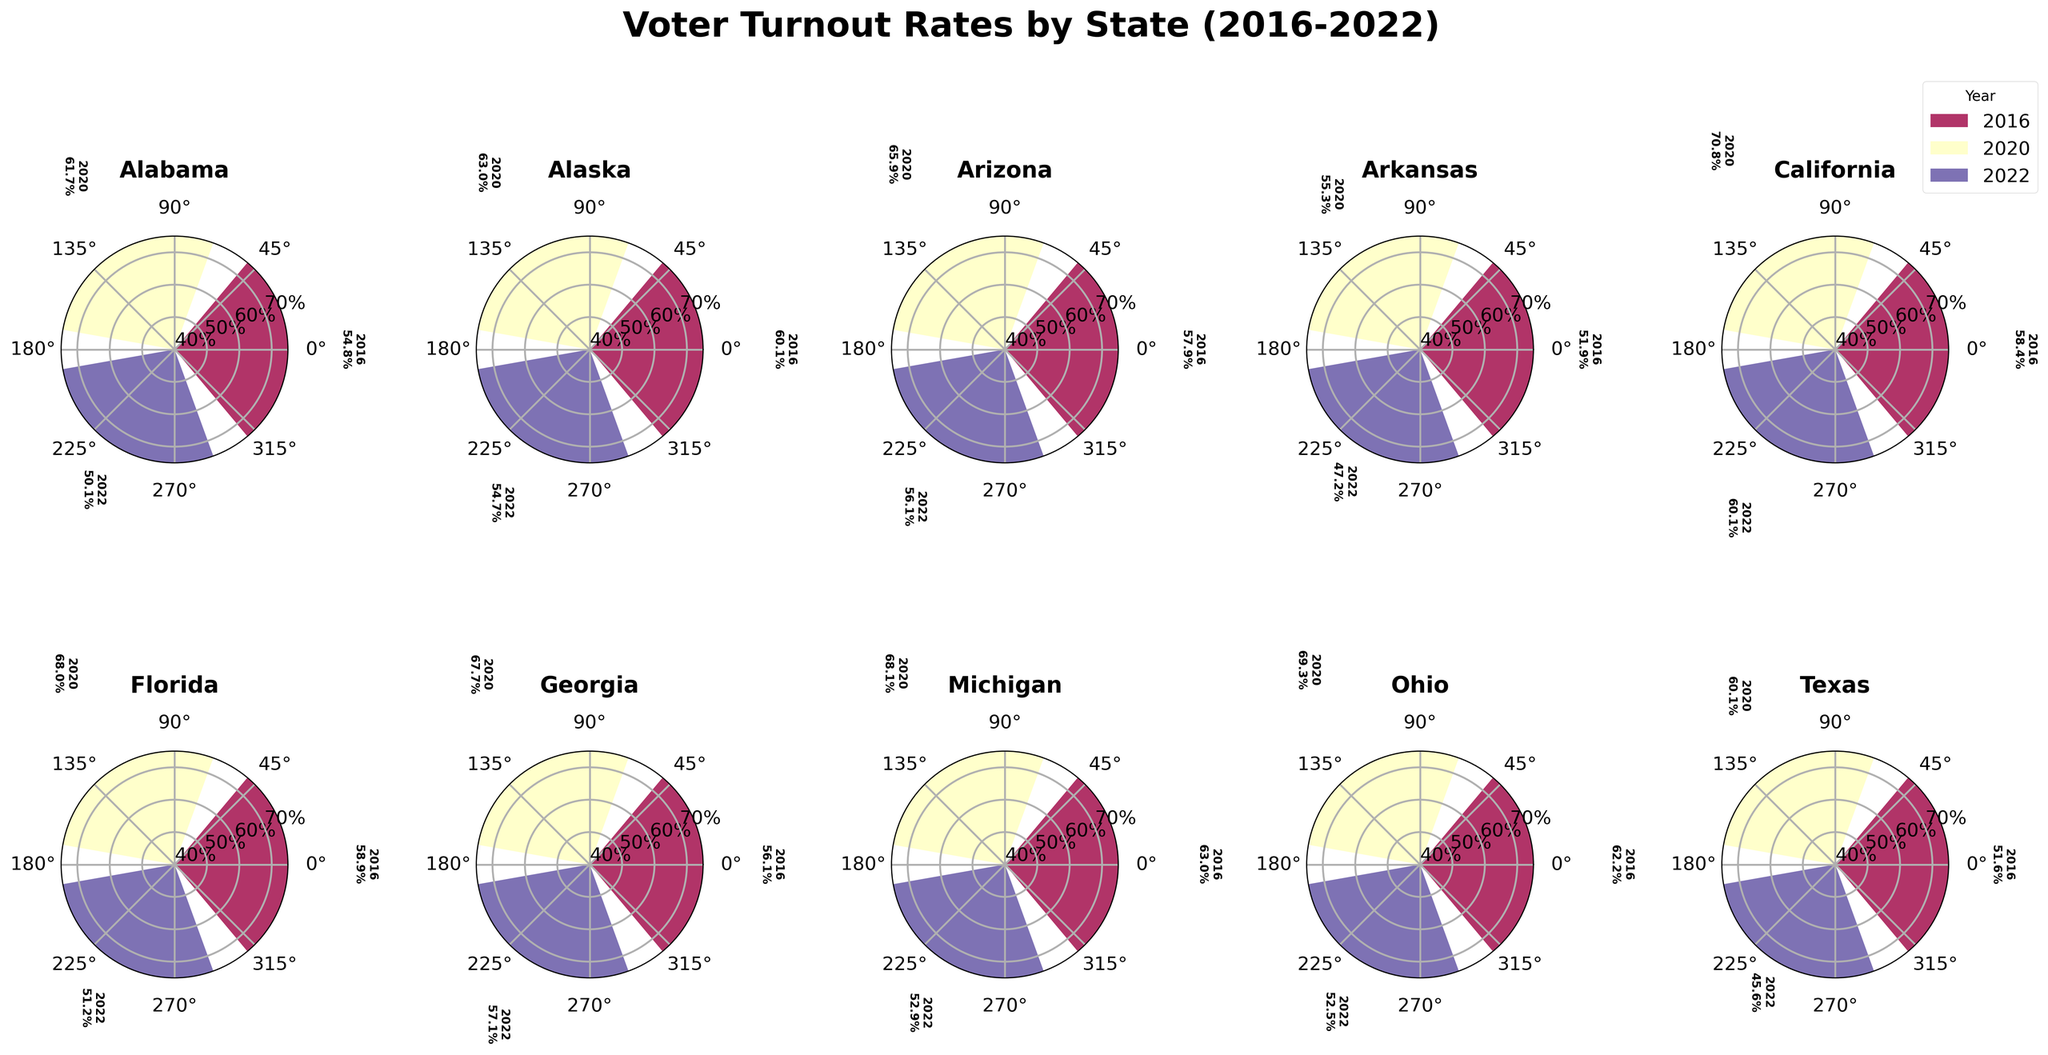how many states are represented in the figure? Count the number of unique states listed as titles above each subplot. There are 10 states represented in the figure.
Answer: 10 which year had the highest voter turnout in california? For California's subplot, compare the voter turnout percentages labeled for each year (2016, 2020, 2022). The highest turnout is for the year 2020 with 70.8%.
Answer: 2020 what is the range of voter turnout rates in florida over the past three elections? Identify the highest and lowest voter turnout rates for Florida (68.0% in 2020 and 51.2% in 2022). Calculate the range by subtracting the lowest value from the highest value (68.0 - 51.2).
Answer: 16.8% which state had the lowest voter turnout in 2022? For each state's subplot, identify the bar corresponding to the year 2022 and compare the heights. Texas has the lowest turnout in 2022 with 45.6%.
Answer: Texas did voter turnout in ohio increase or decrease from 2020 to 2022? Look at Ohio's subplot and compare the voter turnout percentages for 2020 (69.3%) and 2022 (52.5%). The voter turnout decreased.
Answer: decreased calculate the average voter turnout in michigan over the past three elections. Add the voter turnout percentages for Michigan over the past three elections (63.0% for 2016, 68.1% for 2020, and 52.9% for 2022). Divide the sum by 3 to get the average: (63.0 + 68.1 + 52.9) / 3 = 61.3%.
Answer: 61.3% compare the voter turnout trends between texas and ohio from 2016 to 2022. Examine the trends in voter turnout for both Texas and Ohio from 2016 to 2022. Texas shows a decrease from 2016 (51.6%) to 2022 (45.6%), while Ohio shows a decrease from 2016 (62.2%) to 2022 (52.5%). Both states experienced a decrease in voter turnout over this period.
Answer: Both decreased which state had the highest overall voter turnout in any year? Compare the highest voter turnout rates shown in each subplot. California's 2020 turnout of 70.8% is the highest.
Answer: California (2020) 